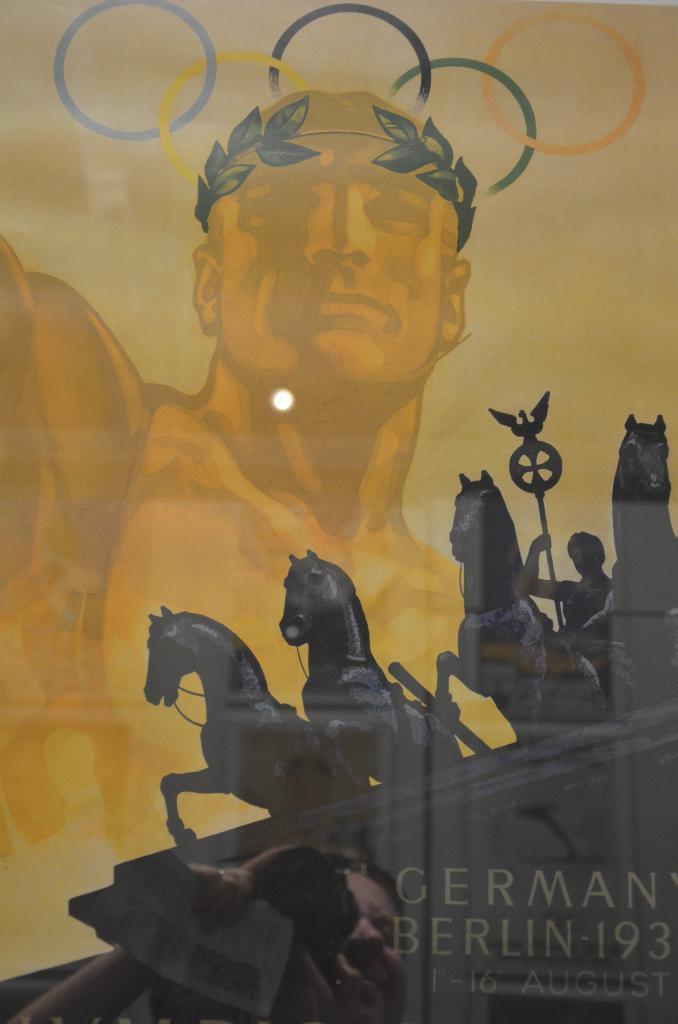In one or two sentences, can you explain what this image depicts? In this picture, it looks like a transparent material. Behind the transparent material, there is a poster of an "Olympic emblem" and sculptures of horses. On the poster, it is written something. On the transparent material, we can see the reflection of a person and light. 